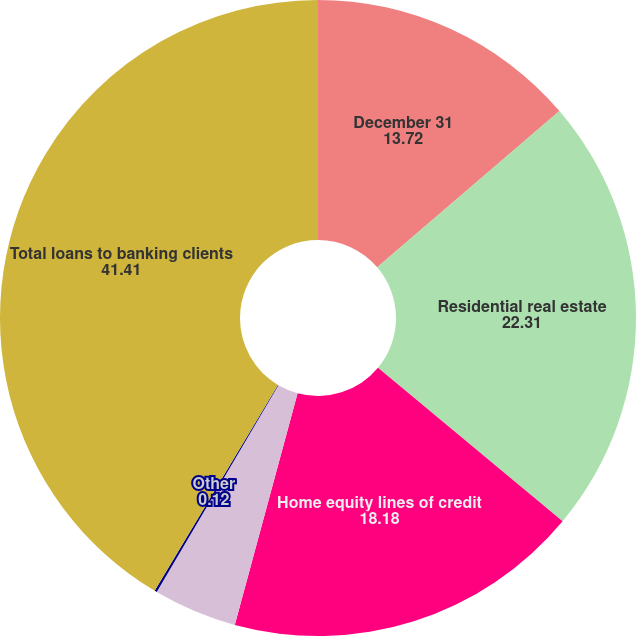<chart> <loc_0><loc_0><loc_500><loc_500><pie_chart><fcel>December 31<fcel>Residential real estate<fcel>Home equity lines of credit<fcel>Personal loans secured by<fcel>Other<fcel>Total loans to banking clients<nl><fcel>13.72%<fcel>22.31%<fcel>18.18%<fcel>4.25%<fcel>0.12%<fcel>41.41%<nl></chart> 